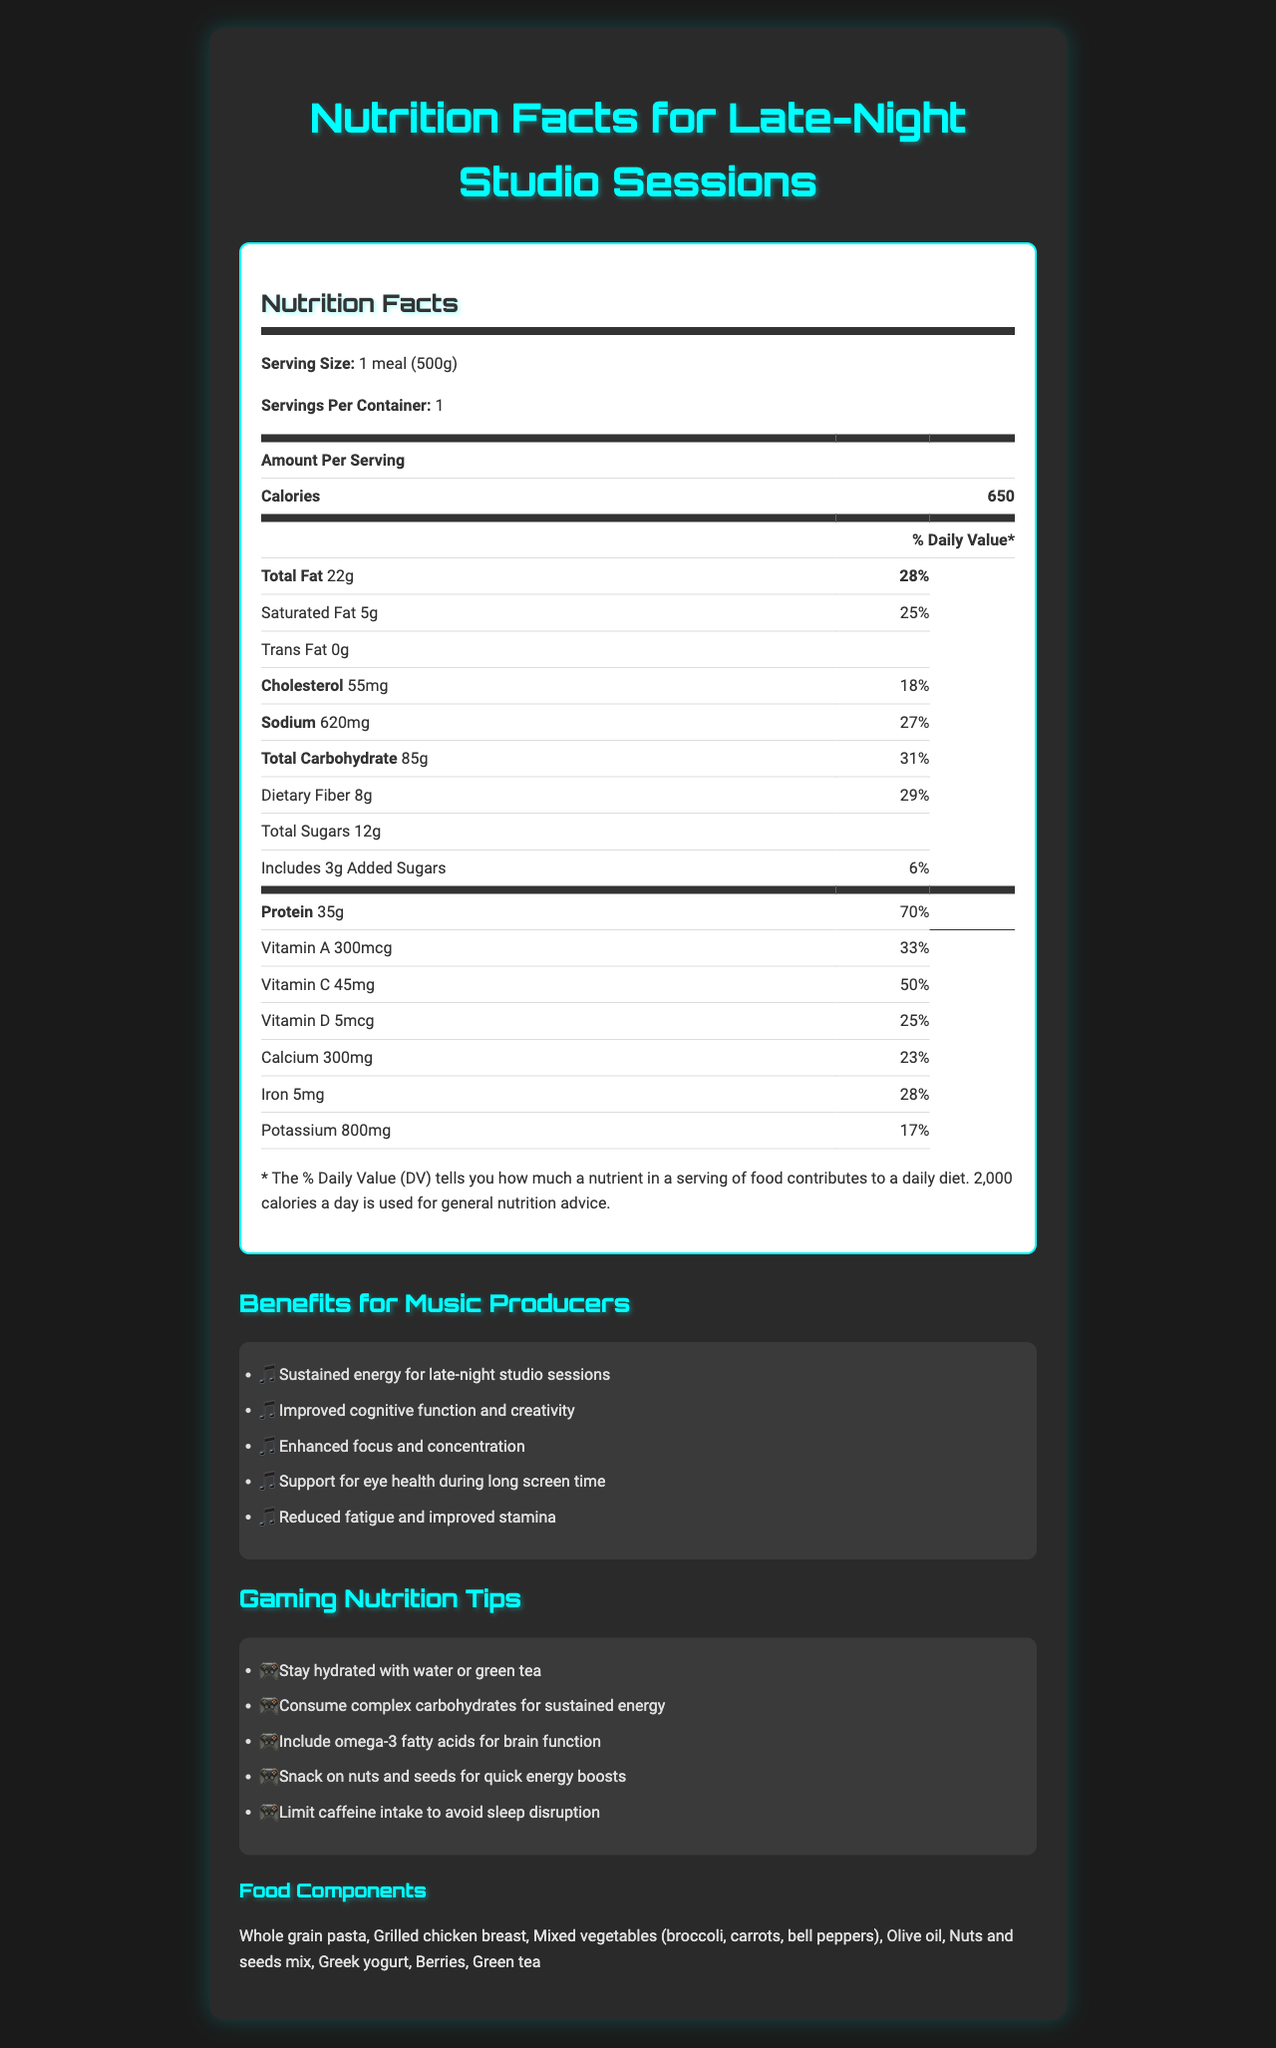what is the serving size for the balanced meal plan? The serving size is clearly mentioned as "1 meal (500g)" in the document.
Answer: 1 meal (500g) how many calories are in one serving of this meal? According to the document, one serving contains 650 calories.
Answer: 650 what is the total amount of protein in one serving? The document lists the protein content as 35g per serving.
Answer: 35g what is the percentage of the daily value for sodium in this meal? The document shows that the total percentage of the daily value for sodium is 27%.
Answer: 27% what are the main food components in this balanced meal plan? The document provides a list of all the food components included in the meal plan.
Answer: Whole grain pasta, Grilled chicken breast, Mixed vegetables (broccoli, carrots, bell peppers), Olive oil, Nuts and seeds mix, Greek yogurt, Berries, Green tea how much vitamin C does the meal provide? A. 45mg B. 50mg C. 30mg D. 25mg The amount of vitamin C per serving is listed as 45mg in the document.
Answer: A what should you consume for quick energy boosts based on the gaming nutrition tips? A. Water B. Green tea C. Nuts and seeds D. Whole grain pasta The gaming nutrition tips recommend snacking on nuts and seeds for quick energy boosts.
Answer: C does this meal contain any trans fat? The document specifies that the trans fat content is 0g, meaning it contains no trans fat.
Answer: No what is the main idea of the document? The document provides detailed nutrition information for a balanced meal, outlines its benefits for late-night productivity, and offers tips for maintaining energy and focus during gaming sessions.
Answer: Describes the nutrition facts and components of a balanced meal plan tailored for late-night studio sessions, highlighting benefits for music producers and offering gaming nutrition tips. how much iron is included in one serving of this meal? The document shows that one serving contains 5mg of iron.
Answer: 5mg is the caffeine content of this meal plan intended to keep you awake for long sessions? The document lists caffeine content as 80mg, which can help in staying awake during long sessions.
Answer: Yes what is the recommended way to stay hydrated according to the gaming nutrition tips? The gaming nutrition tips in the document suggest staying hydrated with water or green tea.
Answer: Water or green tea what is the percentage of the daily value for vitamin B12 in this meal? The document states that the percentage daily value for vitamin B12 in the meal is 83%.
Answer: 83% what benefits does this meal plan provide for music producers? The document outlines these specific benefits for music producers.
Answer: Sustained energy for late-night studio sessions, Improved cognitive function and creativity, Enhanced focus and concentration, Support for eye health during long screen time, Reduced fatigue and improved stamina how much omega-3 fatty acids does this meal include? The document mentions that the meal contains 1.2g of omega-3 fatty acids.
Answer: 1.2g what is the total amount of added sugars in this meal? The document indicates that there are 3g of added sugars in the meal.
Answer: 3g what is the daily value percentage for dietary fiber in one serving of this meal? The percentage daily value for dietary fiber in the meal is listed as 29%.
Answer: 29% what should you limit to avoid sleep disruption according to the gaming nutrition tips? The document emphasizes limiting caffeine intake to avoid sleep disruption.
Answer: Caffeine intake what is the total amount of carbohydrates in one serving? The document notes that one serving contains 85g of total carbohydrates.
Answer: 85g which ingredient supports brain function according to the gaming nutrition tips? A. Olive oil B. Omega-3 fatty acids C. Greek yogurt D. Berries The gaming nutrition tips suggest including omega-3 fatty acids for brain function.
Answer: B what is the calcium content in one serving of this meal? The document shows the calcium content as 300mg per serving.
Answer: 300mg can you determine the exact preparation method for the grilled chicken breast? The document lists grilled chicken breast as a food component but does not provide specific preparation methods.
Answer: Not enough information 